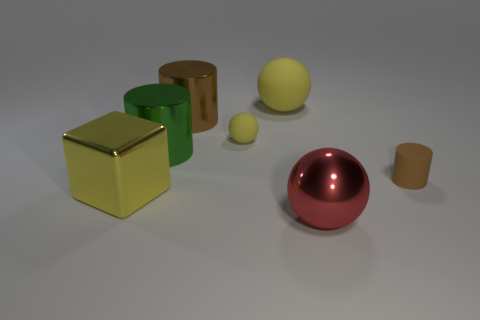How many yellow metallic objects are there?
Offer a terse response. 1. Is there any other thing that has the same material as the big green cylinder?
Your response must be concise. Yes. There is a small brown thing that is the same shape as the green metal thing; what material is it?
Your response must be concise. Rubber. Are there fewer big brown metallic cylinders that are in front of the large green cylinder than metal objects?
Your answer should be very brief. Yes. Does the small matte thing that is in front of the green shiny cylinder have the same shape as the yellow metallic object?
Offer a terse response. No. Is there anything else that is the same color as the big cube?
Provide a succinct answer. Yes. What is the size of the brown object that is the same material as the small yellow object?
Your answer should be compact. Small. What material is the big sphere in front of the small object to the right of the big thing that is on the right side of the big yellow ball?
Offer a terse response. Metal. Are there fewer large brown things than balls?
Offer a very short reply. Yes. Is the small cylinder made of the same material as the big red thing?
Offer a very short reply. No. 